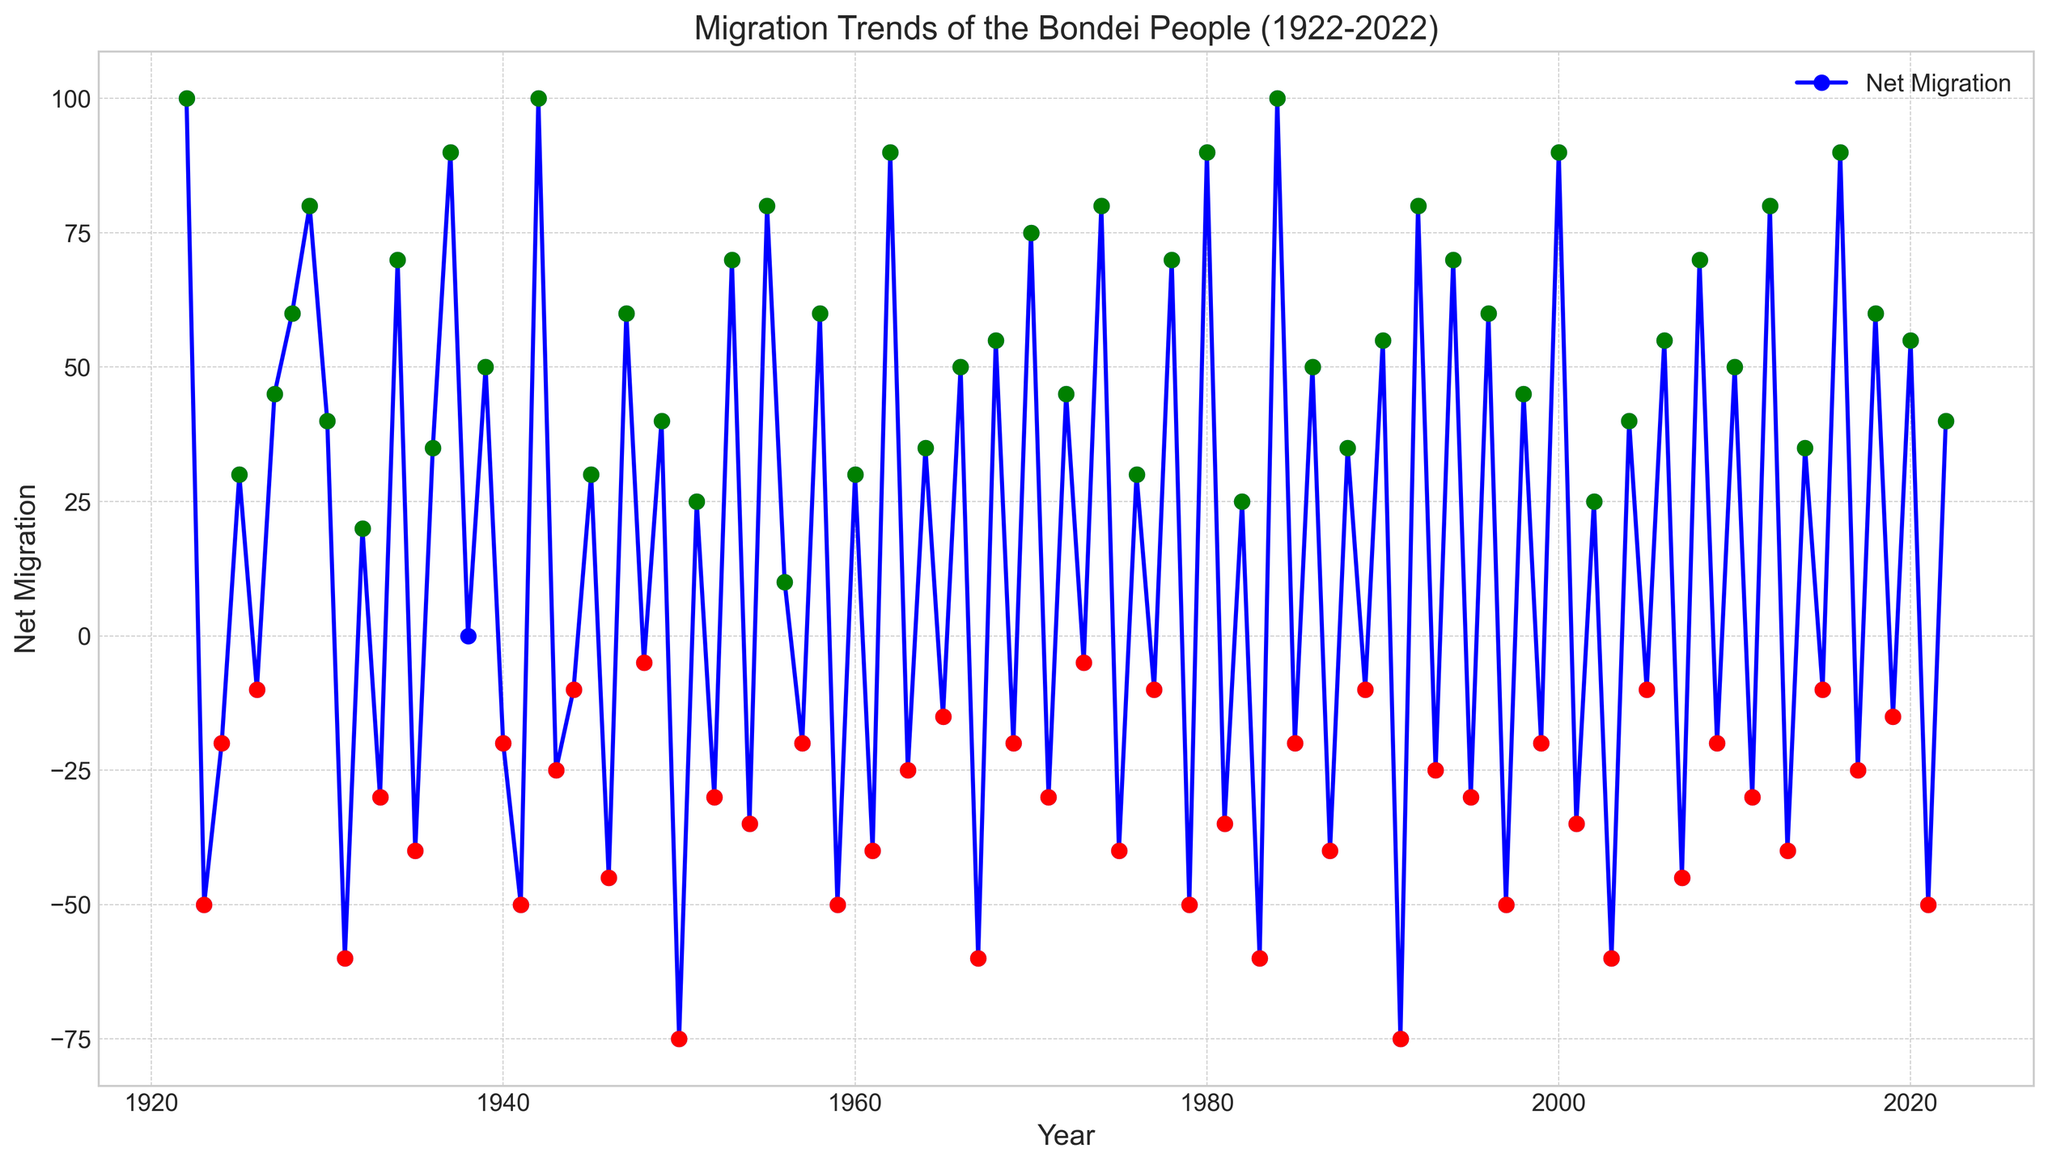Which year saw the highest net migration gain? The figure shows the net migration values over the years with positive peaks identified by green markers. The highest positive value visually appears in 1942 with a green marker at 100.
Answer: 1942 Which year experienced the largest net migration loss? The chart indicates negative peaks by red markers. The largest negative value (i.e., most significant migration loss) occurs in 1950 with a red marker at -75.
Answer: 1950 During which decades did most of the net migration values fluctuate between positive and negative? Observing the overall trends, it is apparent that from the 1920s to the 1990s, annual net migration values consistently alternate between positive and negative values, as highlighted by alternating red and green markers.
Answer: 1920s to 1990s What is the net migration trend from 2000 to 2022? By examining the line from 2000 onwards, it is observed that the values show both positive gains and negative losses. The early 2000s show some positive values, while the later years, especially till 2022, show a mix of positive and negative values.
Answer: Mixed trend Which five-year period had the most significant cumulative net migration loss? Sum up the net migration values for every consecutive five-year period and compare. Period 2017-2021 has significant ups and downs: (2017: -25, 2018: 60, 2019: -15, 2020: 55, 2021: -50). The total is 25. Another negative period is 1977-1981: (1977: -10, 1978: 70, 1979: -50, 1980: 90, 1981: -35 which totals to 65). The period 1971-1975: (1971: -30, 1972: 45, 1973: -5, 1974: 80, 1975: -40), results in a net 50. The maximum loss occurs as cumulative losses from 1967-1971: (1967: -60, 1968: 55, 1969: -20, 1970: 75, 1971: -30) summing up to a loss of 55.
Answer: 1967-1971 What is the overall trend of net migration from 1922 to 2022? The general trend shows alternating patterns of gains and losses. Periods of net migration gain alternate with years of loss, especially marked in recent decades, indicating no consistent long-term positive or negative trend but rather a fluctuating pattern.
Answer: Fluctuating Which year had positive migration followed immediately by a negative migration? For every year with positive migration, confirm if the subsequent year is negative. Checking data: positive migration in 1922 (100) followed by negative in 1923 (-50), again in 1924 (-20) followed by positive in 1925 (30) thus, 1922 is the first instance we need. One such instance confirmation:
Answer: 1922 What are the cumulative net migration values for the 1920s? Sum up the annual net migration values from 1922 to 1929. (100 - 50 - 20 + 30 - 10 + 45 + 60 + 80 = 235).
Answer: 235 